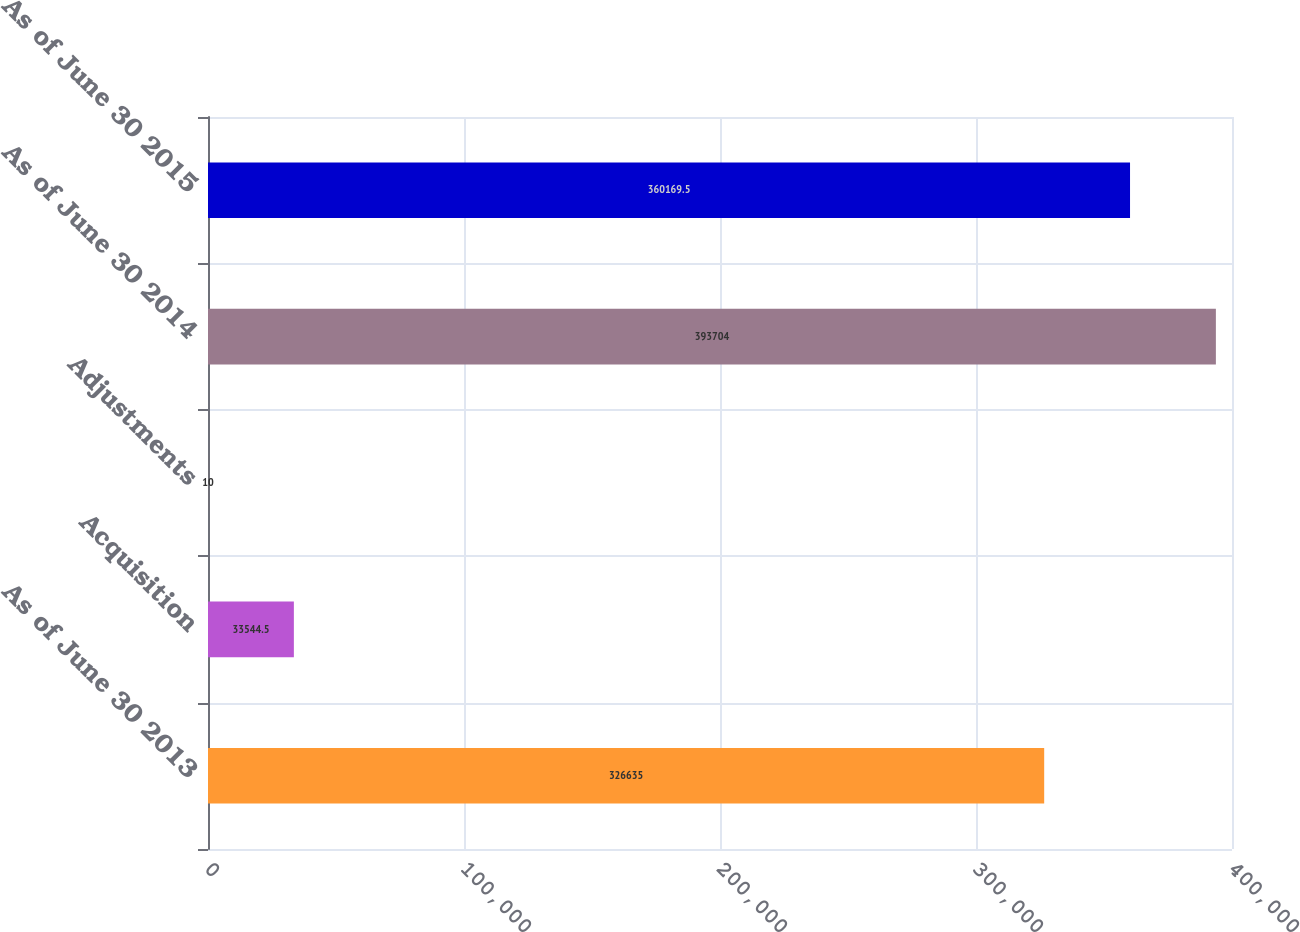Convert chart. <chart><loc_0><loc_0><loc_500><loc_500><bar_chart><fcel>As of June 30 2013<fcel>Acquisition<fcel>Adjustments<fcel>As of June 30 2014<fcel>As of June 30 2015<nl><fcel>326635<fcel>33544.5<fcel>10<fcel>393704<fcel>360170<nl></chart> 